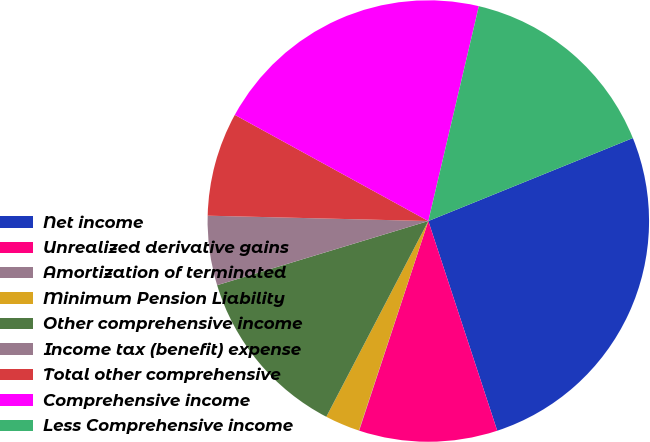Convert chart to OTSL. <chart><loc_0><loc_0><loc_500><loc_500><pie_chart><fcel>Net income<fcel>Unrealized derivative gains<fcel>Amortization of terminated<fcel>Minimum Pension Liability<fcel>Other comprehensive income<fcel>Income tax (benefit) expense<fcel>Total other comprehensive<fcel>Comprehensive income<fcel>Less Comprehensive income<nl><fcel>26.08%<fcel>10.13%<fcel>0.02%<fcel>2.55%<fcel>12.66%<fcel>5.08%<fcel>7.6%<fcel>20.69%<fcel>15.19%<nl></chart> 